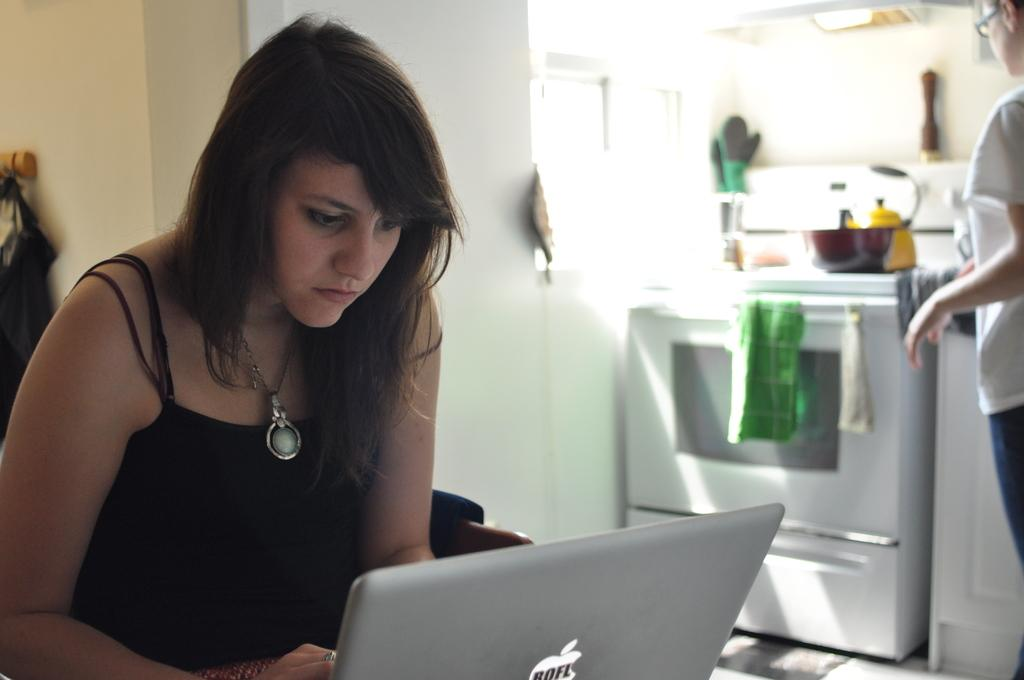<image>
Provide a brief description of the given image. a woman leaning over a mac laptop with a stick "roel" on the brand logo 